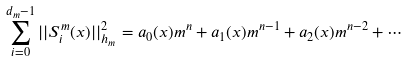<formula> <loc_0><loc_0><loc_500><loc_500>\sum _ { i = 0 } ^ { d _ { m } - 1 } | | S _ { i } ^ { m } ( x ) | | _ { h _ { m } } ^ { 2 } = a _ { 0 } ( x ) m ^ { n } + a _ { 1 } ( x ) m ^ { n - 1 } + a _ { 2 } ( x ) m ^ { n - 2 } + \cdots</formula> 